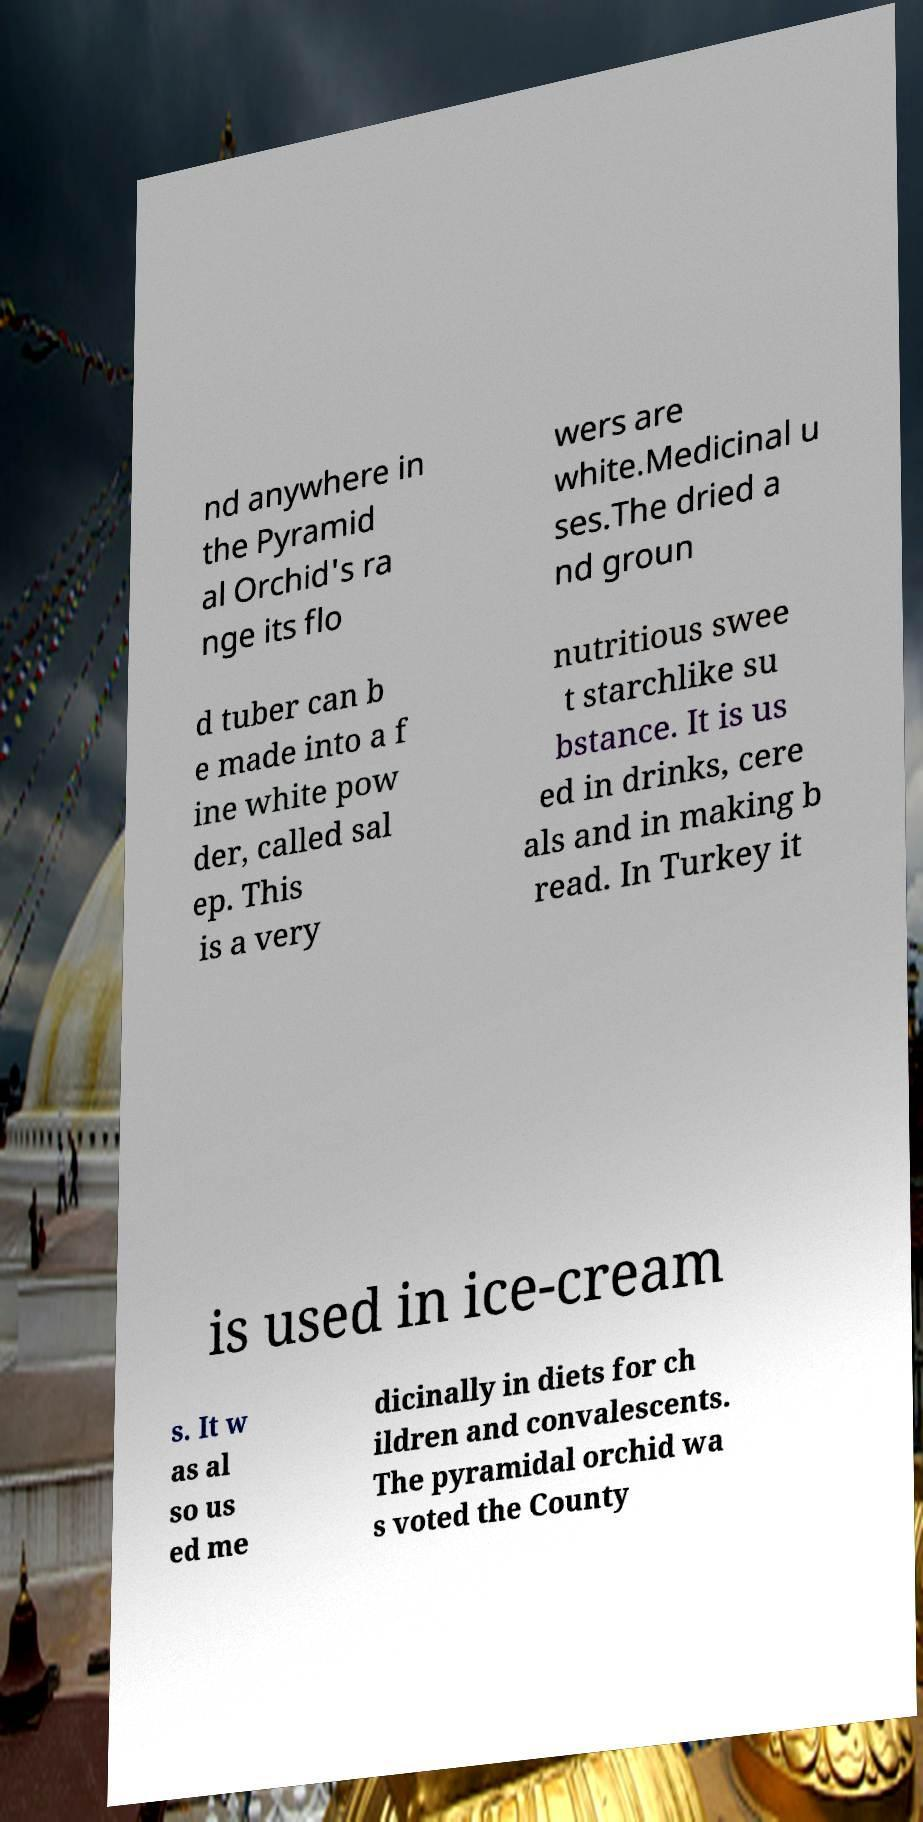What messages or text are displayed in this image? I need them in a readable, typed format. nd anywhere in the Pyramid al Orchid's ra nge its flo wers are white.Medicinal u ses.The dried a nd groun d tuber can b e made into a f ine white pow der, called sal ep. This is a very nutritious swee t starchlike su bstance. It is us ed in drinks, cere als and in making b read. In Turkey it is used in ice-cream s. It w as al so us ed me dicinally in diets for ch ildren and convalescents. The pyramidal orchid wa s voted the County 